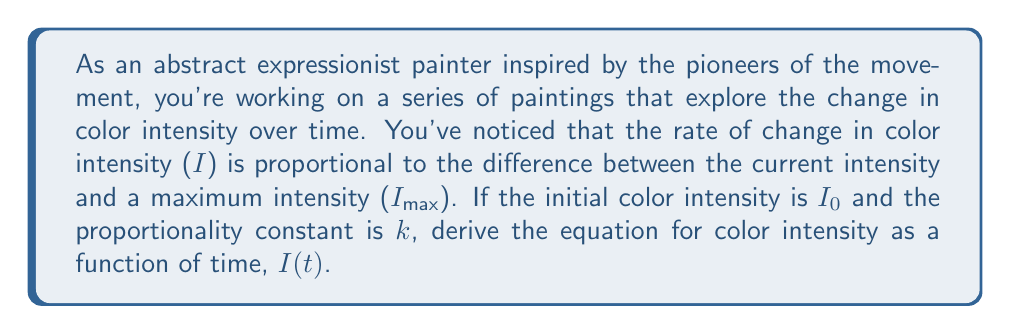Can you solve this math problem? Let's approach this step-by-step:

1) First, we need to formulate the differential equation based on the given information. The rate of change of intensity with respect to time is proportional to the difference between the maximum intensity and the current intensity:

   $$\frac{dI}{dt} = k(I_{max} - I)$$

2) This is a first-order linear differential equation. We can solve it using the separation of variables method.

3) Rearranging the equation:

   $$\frac{dI}{I_{max} - I} = k dt$$

4) Integrating both sides:

   $$\int \frac{dI}{I_{max} - I} = \int k dt$$

5) The left side integrates to $-\ln|I_{max} - I|$, and the right side to $kt + C$:

   $$-\ln|I_{max} - I| = kt + C$$

6) Solving for $I$:

   $$\ln|I_{max} - I| = -kt - C$$
   $$I_{max} - I = e^{-kt - C} = Ae^{-kt}$$, where $A = e^{-C}$
   $$I = I_{max} - Ae^{-kt}$$

7) To find $A$, we use the initial condition. At $t = 0$, $I = I_0$:

   $$I_0 = I_{max} - A$$
   $$A = I_{max} - I_0$$

8) Substituting this back into our equation:

   $$I = I_{max} - (I_{max} - I_0)e^{-kt}$$

This is the final equation for color intensity as a function of time.
Answer: $$I(t) = I_{max} - (I_{max} - I_0)e^{-kt}$$ 